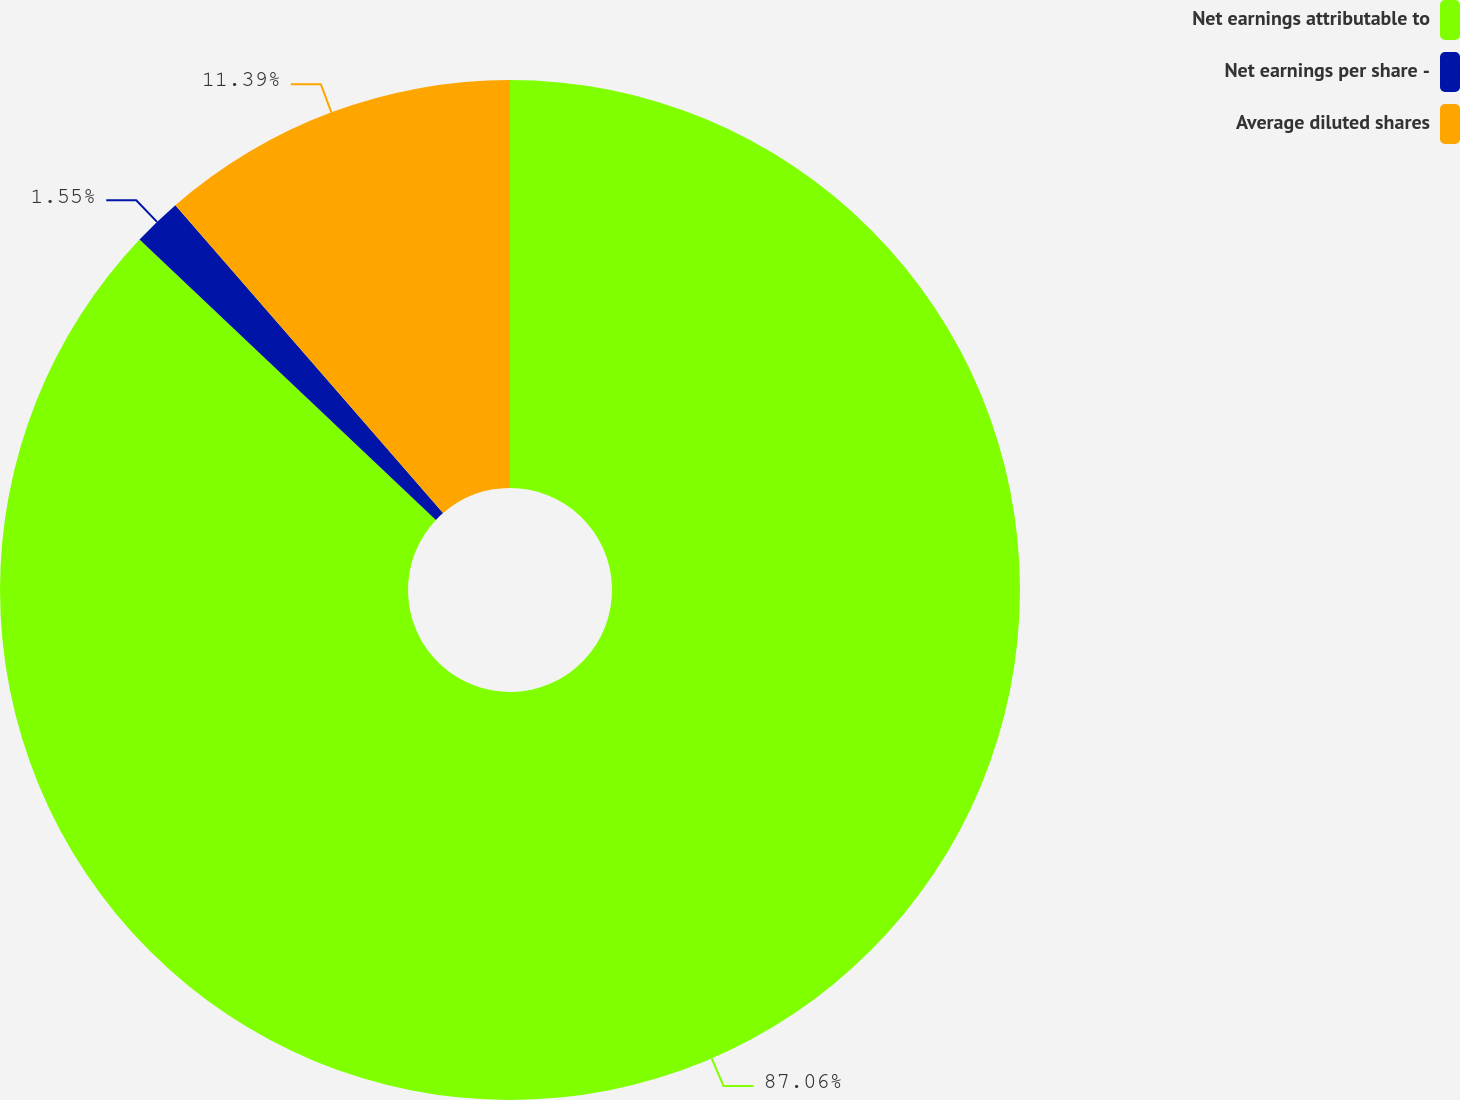Convert chart to OTSL. <chart><loc_0><loc_0><loc_500><loc_500><pie_chart><fcel>Net earnings attributable to<fcel>Net earnings per share -<fcel>Average diluted shares<nl><fcel>87.05%<fcel>1.55%<fcel>11.39%<nl></chart> 